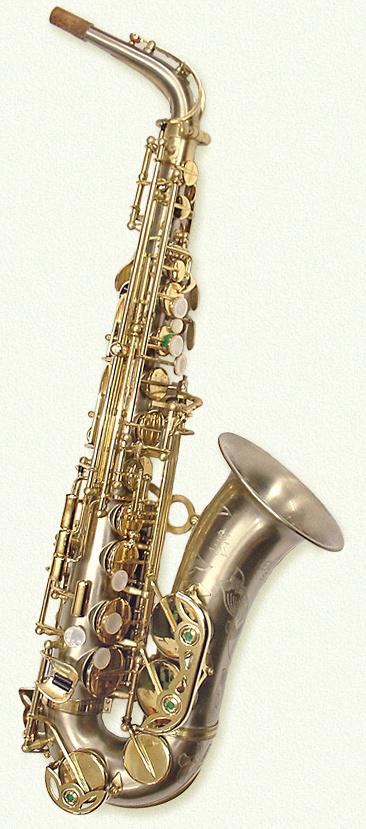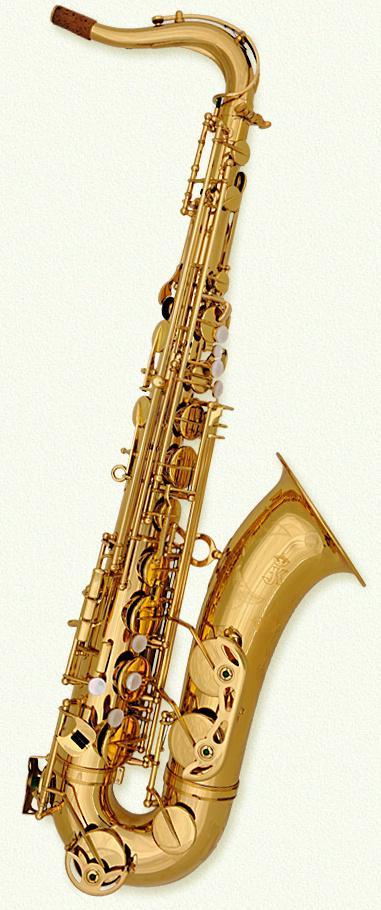The first image is the image on the left, the second image is the image on the right. Analyze the images presented: Is the assertion "Each saxophone is displayed nearly vertically with its bell facing rightward, but the saxophone on the right is a brighter, yellower gold color." valid? Answer yes or no. Yes. The first image is the image on the left, the second image is the image on the right. Considering the images on both sides, is "In at least one image there is a single bras saxophone  with the mouth section tiped left froward with the horn part almost parrellal to the ground." valid? Answer yes or no. No. 